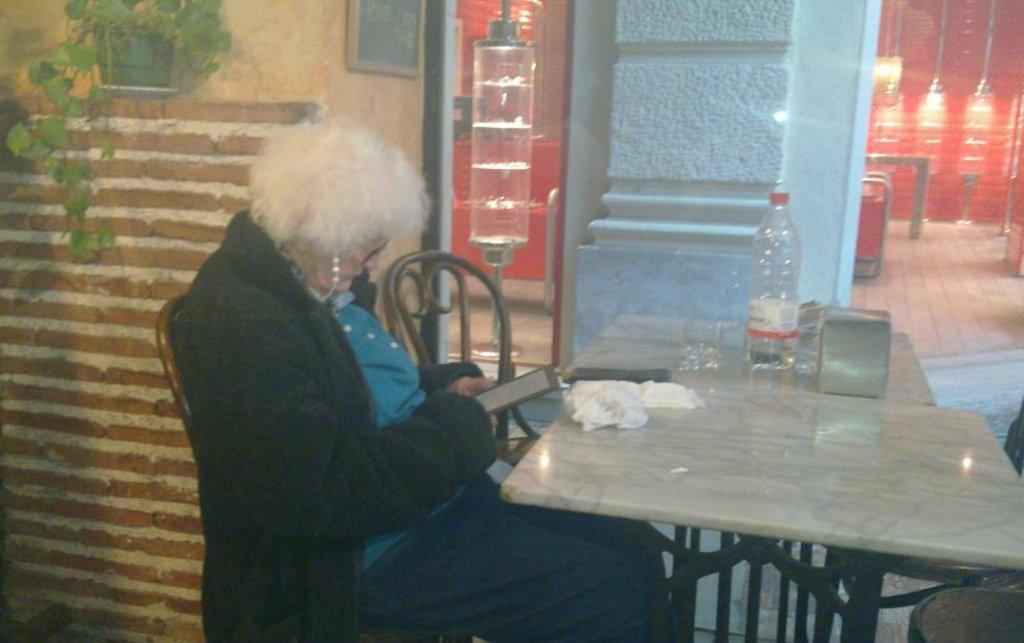Who is present in the image? There is a woman in the image. What is the woman doing in the image? The woman is sitting on a chair. What is the woman wearing in the image? The woman is wearing a black jacket. What is the woman holding in the image? The woman is holding a photo. What objects can be seen on the table in the image? There is a bottle, a glass, and a cloth on the table. What can be seen on the wall in the image? There is a plant on the wall. What type of sun can be seen in the image? There is no sun present in the image. What is the woman reading in the image? The image does not show the woman reading anything. 